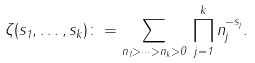<formula> <loc_0><loc_0><loc_500><loc_500>\zeta ( s _ { 1 } , \dots , s _ { k } ) \colon = \sum _ { n _ { 1 } > \cdots > n _ { k } > 0 } \, \prod _ { j = 1 } ^ { k } n _ { j } ^ { - s _ { j } } .</formula> 